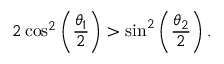<formula> <loc_0><loc_0><loc_500><loc_500>2 \cos ^ { 2 } \left ( \frac { \theta _ { 1 } } { 2 } \right ) > \sin ^ { 2 } \left ( \frac { \theta _ { 2 } } { 2 } \right ) .</formula> 